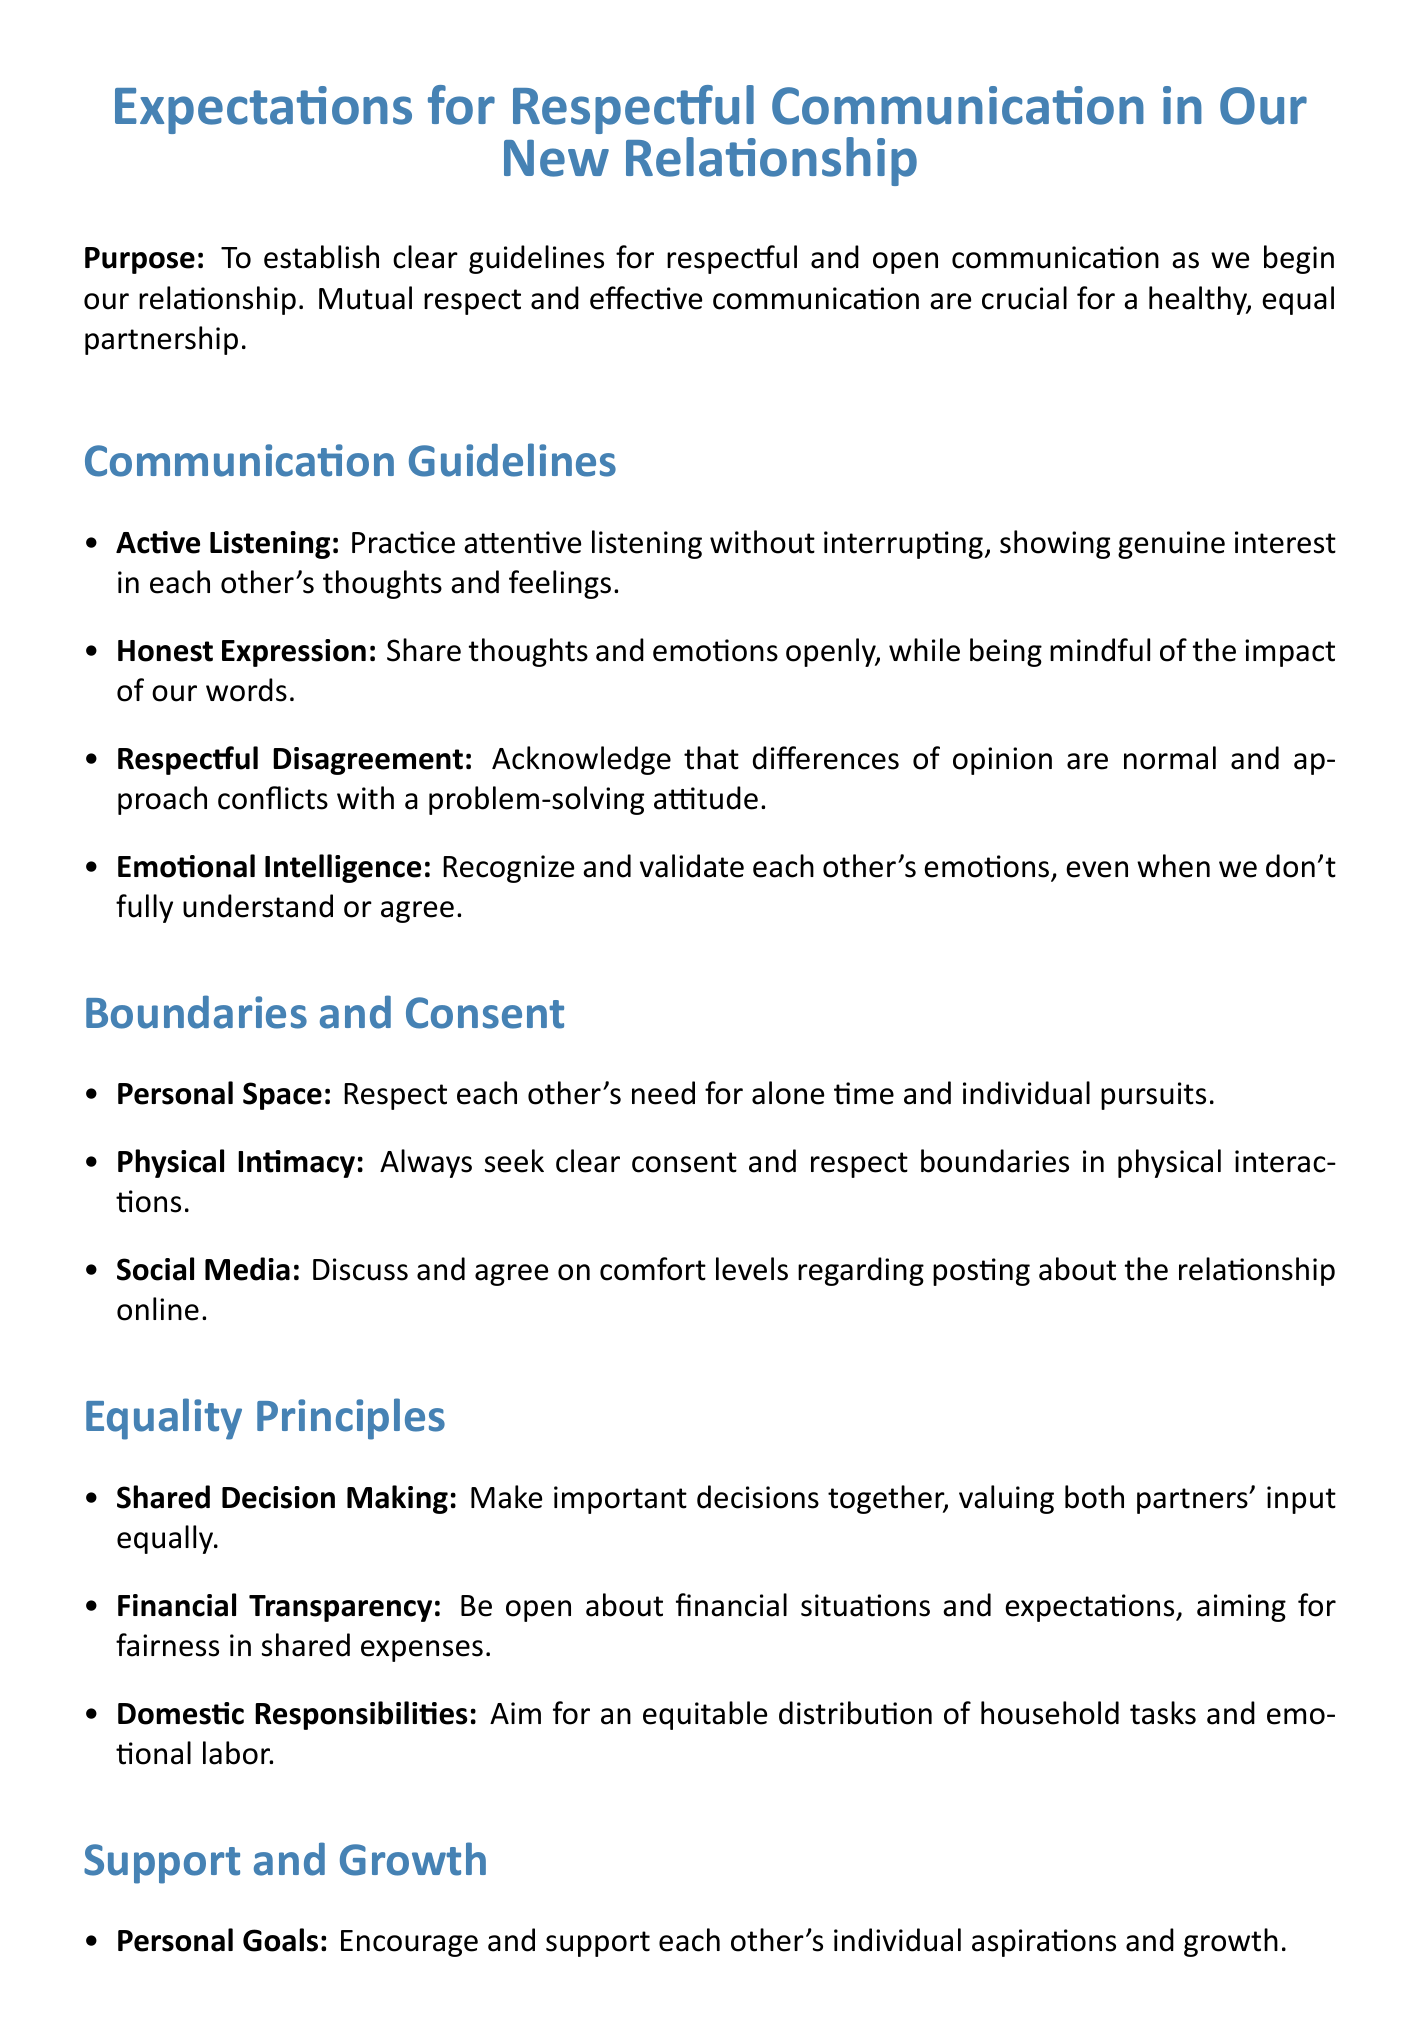What is the title of the memo? The title of the memo provides a clear indication of its content regarding communication expectations in a new relationship.
Answer: Expectations for Respectful Communication in Our New Relationship Who are the signatories of the memo? The signatories of the memo represent both partners involved in the relationship.
Answer: Michelle, David What date was the memo signed? The date indicates when the guidelines were formally agreed upon by both partners.
Answer: May 15, 2023 What is the first guideline under Communication Guidelines? The first guideline outlines an important practice for effective communication between partners.
Answer: Active Listening What is the expectation regarding Personal Space? This expectation highlights an important aspect of respect for individuality in the relationship.
Answer: Respect each other's need for alone time and individual pursuits How many principles are outlined under Equality Principles? This question assesses the principles that govern equality within the relationship, reflecting their commitment to fairness and shared input.
Answer: Three What area is focused on providing support during challenging times? This indicates a specific aspect of emotional well-being that partners commit to consider.
Answer: Emotional Support What aspect of technology is emphasized regarding tone? This relates to how partners should communicate via written messages, which can often lead to misunderstandings without verbal cues.
Answer: Text Communication What does the conclusion suggest about the expectations? The conclusion emphasizes the ongoing nature of this document, highlighting the importance of adaptability in a relationship.
Answer: Revisiting and refining these expectations 